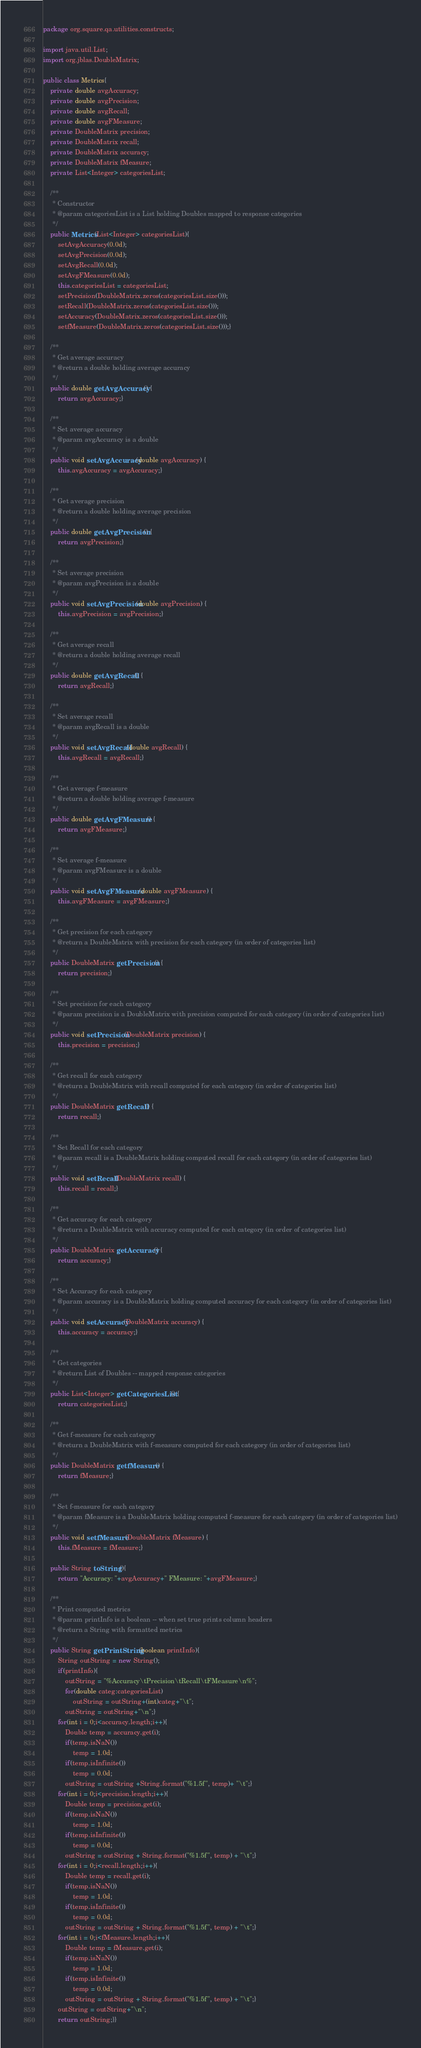Convert code to text. <code><loc_0><loc_0><loc_500><loc_500><_Java_>package org.square.qa.utilities.constructs;

import java.util.List;
import org.jblas.DoubleMatrix;

public class Metrics{
	private double avgAccuracy;
	private double avgPrecision;
	private double avgRecall;
	private double avgFMeasure;
	private DoubleMatrix precision;
	private DoubleMatrix recall;
	private DoubleMatrix accuracy;
	private DoubleMatrix fMeasure;
	private List<Integer> categoriesList;
	
	/**
	 * Constructor
	 * @param categoriesList is a List holding Doubles mapped to response categories
	 */
	public Metrics(List<Integer> categoriesList){
		setAvgAccuracy(0.0d);
		setAvgPrecision(0.0d);
		setAvgRecall(0.0d);
		setAvgFMeasure(0.0d);
		this.categoriesList = categoriesList;
		setPrecision(DoubleMatrix.zeros(categoriesList.size()));
		setRecall(DoubleMatrix.zeros(categoriesList.size()));
		setAccuracy(DoubleMatrix.zeros(categoriesList.size()));
		setfMeasure(DoubleMatrix.zeros(categoriesList.size()));}
	
	/**
	 * Get average accuracy
	 * @return a double holding average accuracy
	 */
	public double getAvgAccuracy() {
		return avgAccuracy;}
	
	/**
	 * Set average accuracy
	 * @param avgAccuracy is a double
	 */
	public void setAvgAccuracy(double avgAccuracy) {
		this.avgAccuracy = avgAccuracy;}
	
	/**
	 * Get average precision
	 * @return a double holding average precision
	 */
	public double getAvgPrecision() {
		return avgPrecision;}
	
	/**
	 * Set average precision
	 * @param avgPrecision is a double
	 */
	public void setAvgPrecision(double avgPrecision) {
		this.avgPrecision = avgPrecision;}
	
	/**
	 * Get average recall
	 * @return a double holding average recall 
	 */
	public double getAvgRecall() {
		return avgRecall;}
	
	/**
	 * Set average recall
	 * @param avgRecall is a double 
	 */
	public void setAvgRecall(double avgRecall) {
		this.avgRecall = avgRecall;}
	
	/**
	 * Get average f-measure
	 * @return a double holding average f-measure
	 */
	public double getAvgFMeasure() {
		return avgFMeasure;}
	
	/**
	 * Set average f-measure 
	 * @param avgFMeasure is a double 
	 */
	public void setAvgFMeasure(double avgFMeasure) {
		this.avgFMeasure = avgFMeasure;}
	
	/**
	 * Get precision for each category
	 * @return a DoubleMatrix with precision for each category (in order of categories list)
	 */
	public DoubleMatrix getPrecision() {
		return precision;}
	
	/**
	 * Set precision for each category
	 * @param precision is a DoubleMatrix with precision computed for each category (in order of categories list)
	 */
	public void setPrecision(DoubleMatrix precision) {
		this.precision = precision;}
	
	/**
	 * Get recall for each category
	 * @return a DoubleMatrix with recall computed for each category (in order of categories list)
	 */
	public DoubleMatrix getRecall() {
		return recall;}
	
	/**
	 * Set Recall for each category
	 * @param recall is a DoubleMatrix holding computed recall for each category (in order of categories list)
	 */
	public void setRecall(DoubleMatrix recall) {
		this.recall = recall;}
	
	/**
	 * Get accuracy for each category
	 * @return a DoubleMatrix with accuracy computed for each category (in order of categories list)
	 */
	public DoubleMatrix getAccuracy() {
		return accuracy;}
	
	/**
	 * Set Accuracy for each category
	 * @param accuracy is a DoubleMatrix holding computed accuracy for each category (in order of categories list)
	 */
	public void setAccuracy(DoubleMatrix accuracy) {
		this.accuracy = accuracy;}
	
	/**
	 * Get categories 
	 * @return List of Doubles -- mapped response categories
	 */
	public List<Integer> getCategoriesList() {
		return categoriesList;}
	
	/**
	 * Get f-measure for each category
	 * @return a DoubleMatrix with f-measure computed for each category (in order of categories list)
	 */
	public DoubleMatrix getfMeasure() {
		return fMeasure;}
	
	/**
	 * Set f-measure for each category
	 * @param fMeasure is a DoubleMatrix holding computed f-measure for each category (in order of categories list)
	 */
	public void setfMeasure(DoubleMatrix fMeasure) {
		this.fMeasure = fMeasure;}
	
	public String toString(){
		return "Accuracy: "+avgAccuracy+" FMeasure: "+avgFMeasure;}
	
	/**
	 * Print computed metrics
	 * @param printInfo is a boolean -- when set true prints column headers
	 * @return a String with formatted metrics
	 */
	public String getPrintString(boolean printInfo){
		String outString = new String();
		if(printInfo){
			outString = "%Accuracy\tPrecision\tRecall\tFMeasure\n%";
			for(double categ:categoriesList)
				outString = outString+(int)categ+"\t";
			outString = outString+"\n";}
		for(int i = 0;i<accuracy.length;i++){
			Double temp = accuracy.get(i);
			if(temp.isNaN())
				temp = 1.0d;
			if(temp.isInfinite())
				temp = 0.0d;
			outString = outString +String.format("%1.5f", temp)+ "\t";}
		for(int i = 0;i<precision.length;i++){
			Double temp = precision.get(i);
			if(temp.isNaN())
				temp = 1.0d;
			if(temp.isInfinite())
				temp = 0.0d;
			outString = outString + String.format("%1.5f", temp) + "\t";}
		for(int i = 0;i<recall.length;i++){
			Double temp = recall.get(i);
			if(temp.isNaN())
				temp = 1.0d;
			if(temp.isInfinite())
				temp = 0.0d;
			outString = outString + String.format("%1.5f", temp) + "\t";}
		for(int i = 0;i<fMeasure.length;i++){
			Double temp = fMeasure.get(i);
			if(temp.isNaN())
				temp = 1.0d;
			if(temp.isInfinite())
				temp = 0.0d;
			outString = outString + String.format("%1.5f", temp) + "\t";}
		outString = outString+"\n";
		return outString;}}
</code> 